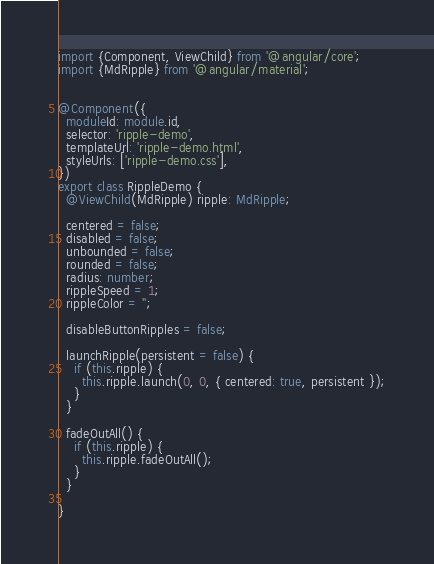Convert code to text. <code><loc_0><loc_0><loc_500><loc_500><_TypeScript_>import {Component, ViewChild} from '@angular/core';
import {MdRipple} from '@angular/material';


@Component({
  moduleId: module.id,
  selector: 'ripple-demo',
  templateUrl: 'ripple-demo.html',
  styleUrls: ['ripple-demo.css'],
})
export class RippleDemo {
  @ViewChild(MdRipple) ripple: MdRipple;

  centered = false;
  disabled = false;
  unbounded = false;
  rounded = false;
  radius: number;
  rippleSpeed = 1;
  rippleColor = '';

  disableButtonRipples = false;

  launchRipple(persistent = false) {
    if (this.ripple) {
      this.ripple.launch(0, 0, { centered: true, persistent });
    }
  }

  fadeOutAll() {
    if (this.ripple) {
      this.ripple.fadeOutAll();
    }
  }

}
</code> 